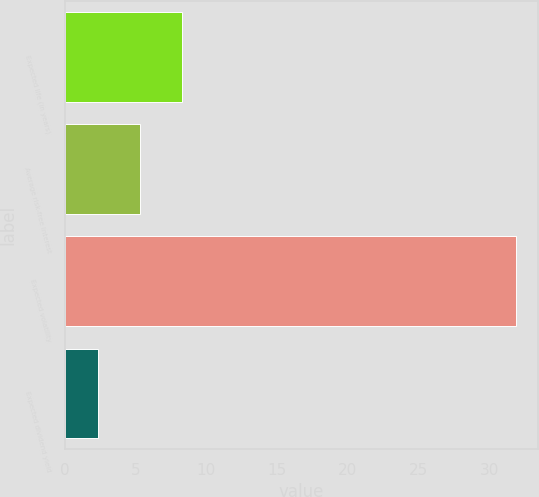Convert chart. <chart><loc_0><loc_0><loc_500><loc_500><bar_chart><fcel>Expected life (in years)<fcel>Average risk-free interest<fcel>Expected volatility<fcel>Expected dividend yield<nl><fcel>8.26<fcel>5.31<fcel>31.9<fcel>2.36<nl></chart> 